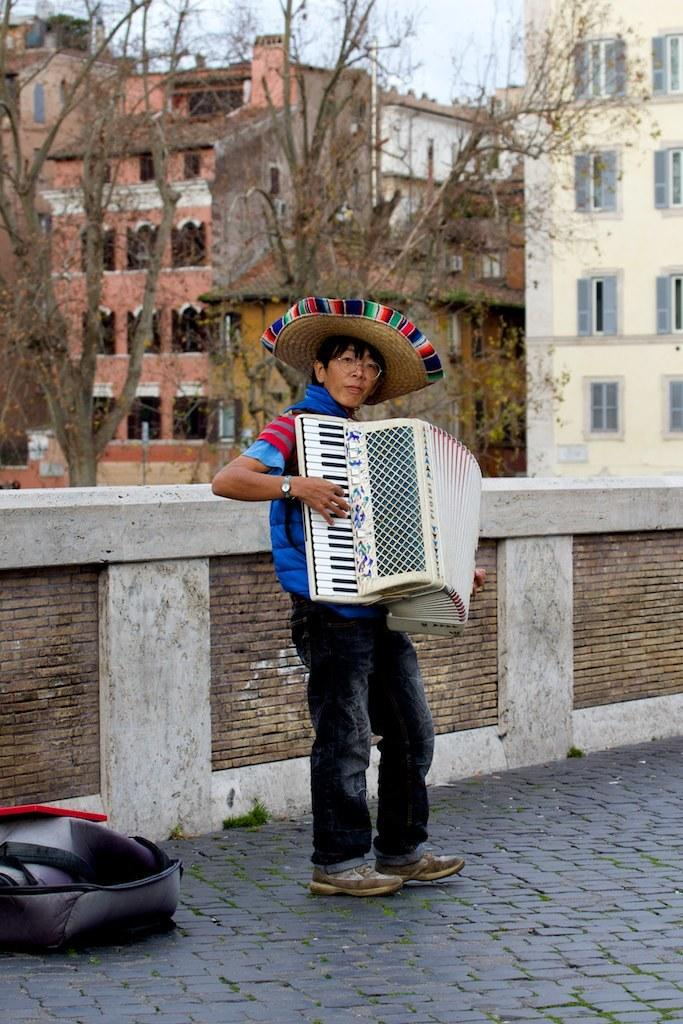What is the person in the image doing? The person is playing a harmonium in the image. What can be seen behind the person? There is a wall behind the person. What type of vegetation is visible in the image? There are dry trees visible in the image. What structures can be seen in the background of the image? There are buildings in the background of the image. Can you see a ship sailing in the background of the image? No, there is no ship visible in the image. What type of can is being used by the person playing the harmonium? There is no can present in the image; the person is playing a harmonium. 